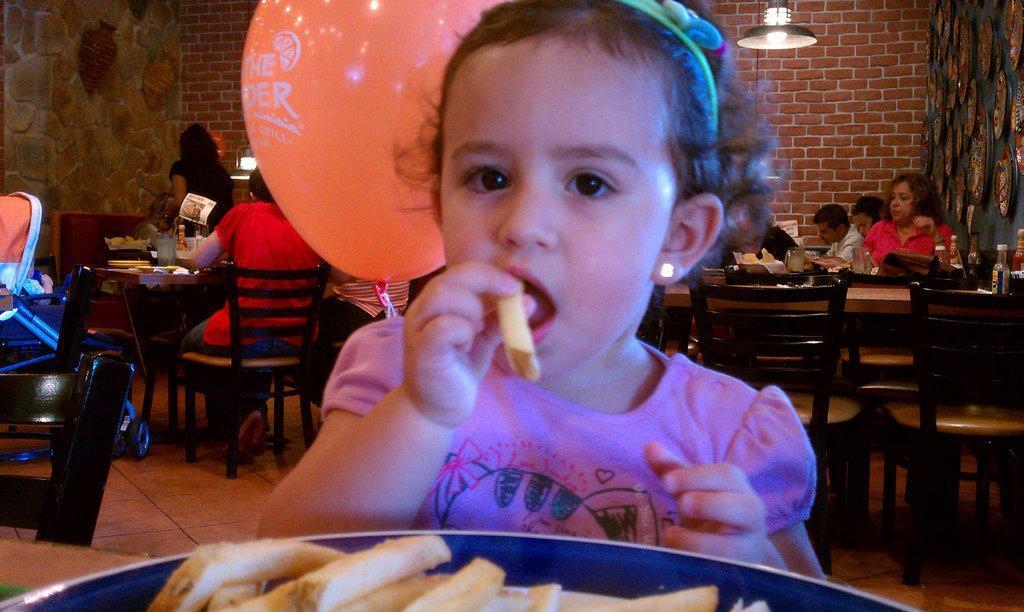How would you summarize this image in a sentence or two? This picture is clicked in the restaurant. There are many tables and chairs in the restaurant. People are sitting on chairs at the tables. At the center of the image there is a girl sitting on chair holding food in her hand. Behind her there is a orange balloon with text on it. There are lamps hanging to the ceiling. In the background there is wall of red bricks. 